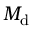Convert formula to latex. <formula><loc_0><loc_0><loc_500><loc_500>M _ { d }</formula> 